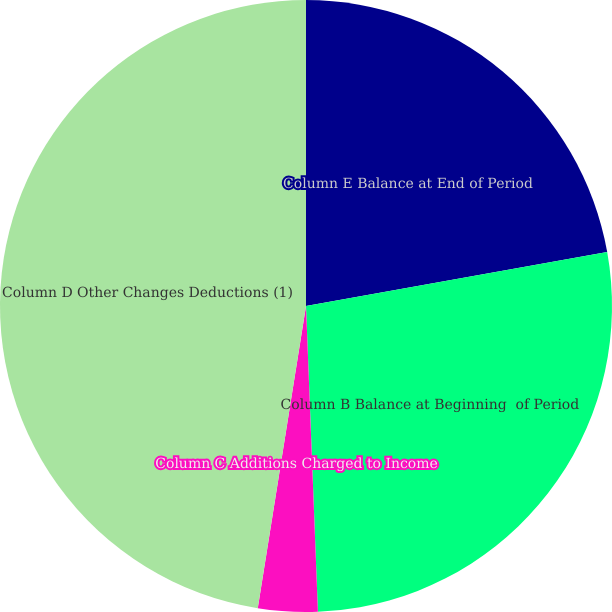Convert chart to OTSL. <chart><loc_0><loc_0><loc_500><loc_500><pie_chart><fcel>Column E Balance at End of Period<fcel>Column B Balance at Beginning  of Period<fcel>Column C Additions Charged to Income<fcel>Column D Other Changes Deductions (1)<nl><fcel>22.18%<fcel>27.2%<fcel>3.14%<fcel>47.48%<nl></chart> 